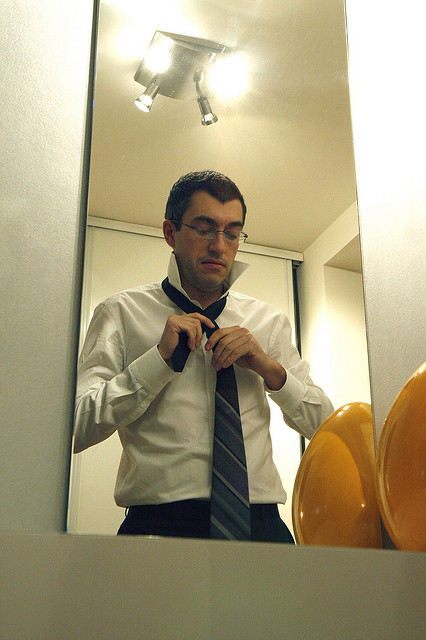Imagine if the room had a window, what kind of view might it have? If the room had a window, it might offer a view of a bustling cityscape, reflecting the man's professional attire and the urban setting suggested by the scene. Alternatively, it could offer a peaceful suburban view, providing a calm backdrop to his focused preparation. What additional details could enhance the overall scene? Additional details that could enhance the scene include a subtle background like a framed motivational poster, a sleek watch on the man’s wrist indicating punctuality, or a set of neatly arranged grooming products on a counter. These elements would add depth to the narrative of personal preparation and attention to detail. Imagine the man is about to attend a secretive, high-stakes poker game. How would this change the interpretation of his actions? If the man were preparing for a high-stakes poker game, his meticulous adjustment of the necktie could be seen as part of his psychological preparation, aiming to convey confidence and control. The formal attire would be a strategic choice to project an image of professionalism and composure, key traits in maintaining a poker face during intense moments of the game. 